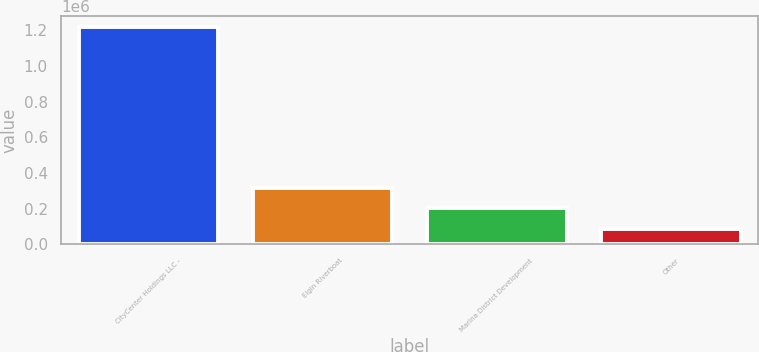<chart> <loc_0><loc_0><loc_500><loc_500><bar_chart><fcel>CityCenter Holdings LLC -<fcel>Elgin Riverboat<fcel>Marina District Development<fcel>Other<nl><fcel>1.22131e+06<fcel>314112<fcel>200713<fcel>87314<nl></chart> 